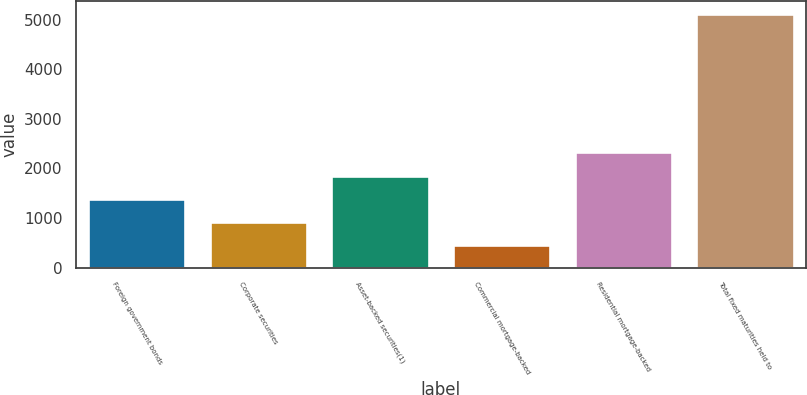<chart> <loc_0><loc_0><loc_500><loc_500><bar_chart><fcel>Foreign government bonds<fcel>Corporate securities<fcel>Asset-backed securities(1)<fcel>Commercial mortgage-backed<fcel>Residential mortgage-backed<fcel>Total fixed maturities held to<nl><fcel>1392<fcel>926<fcel>1858<fcel>460<fcel>2324<fcel>5120<nl></chart> 